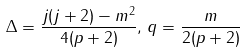Convert formula to latex. <formula><loc_0><loc_0><loc_500><loc_500>\Delta = \frac { j ( j + 2 ) - m ^ { 2 } } { 4 ( p + 2 ) } , \, q = \frac { m } { 2 ( p + 2 ) }</formula> 